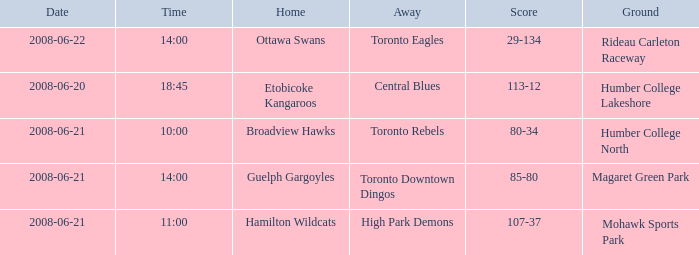What is the Ground with a Date that is 2008-06-20? Humber College Lakeshore. 